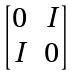Convert formula to latex. <formula><loc_0><loc_0><loc_500><loc_500>\begin{bmatrix} 0 & I \\ I & 0 \end{bmatrix}</formula> 